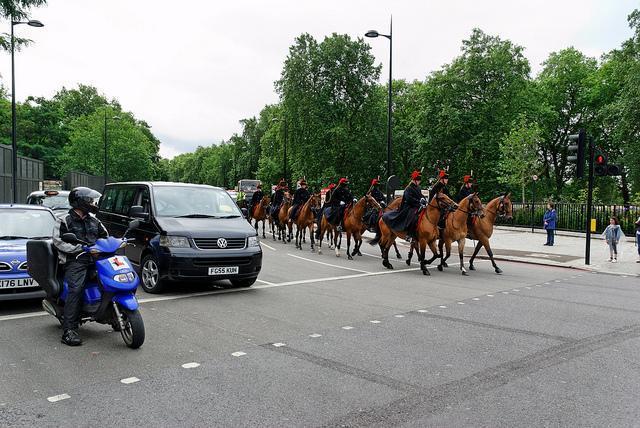How many motorcycles are there?
Give a very brief answer. 1. How many cars are visible?
Give a very brief answer. 2. 